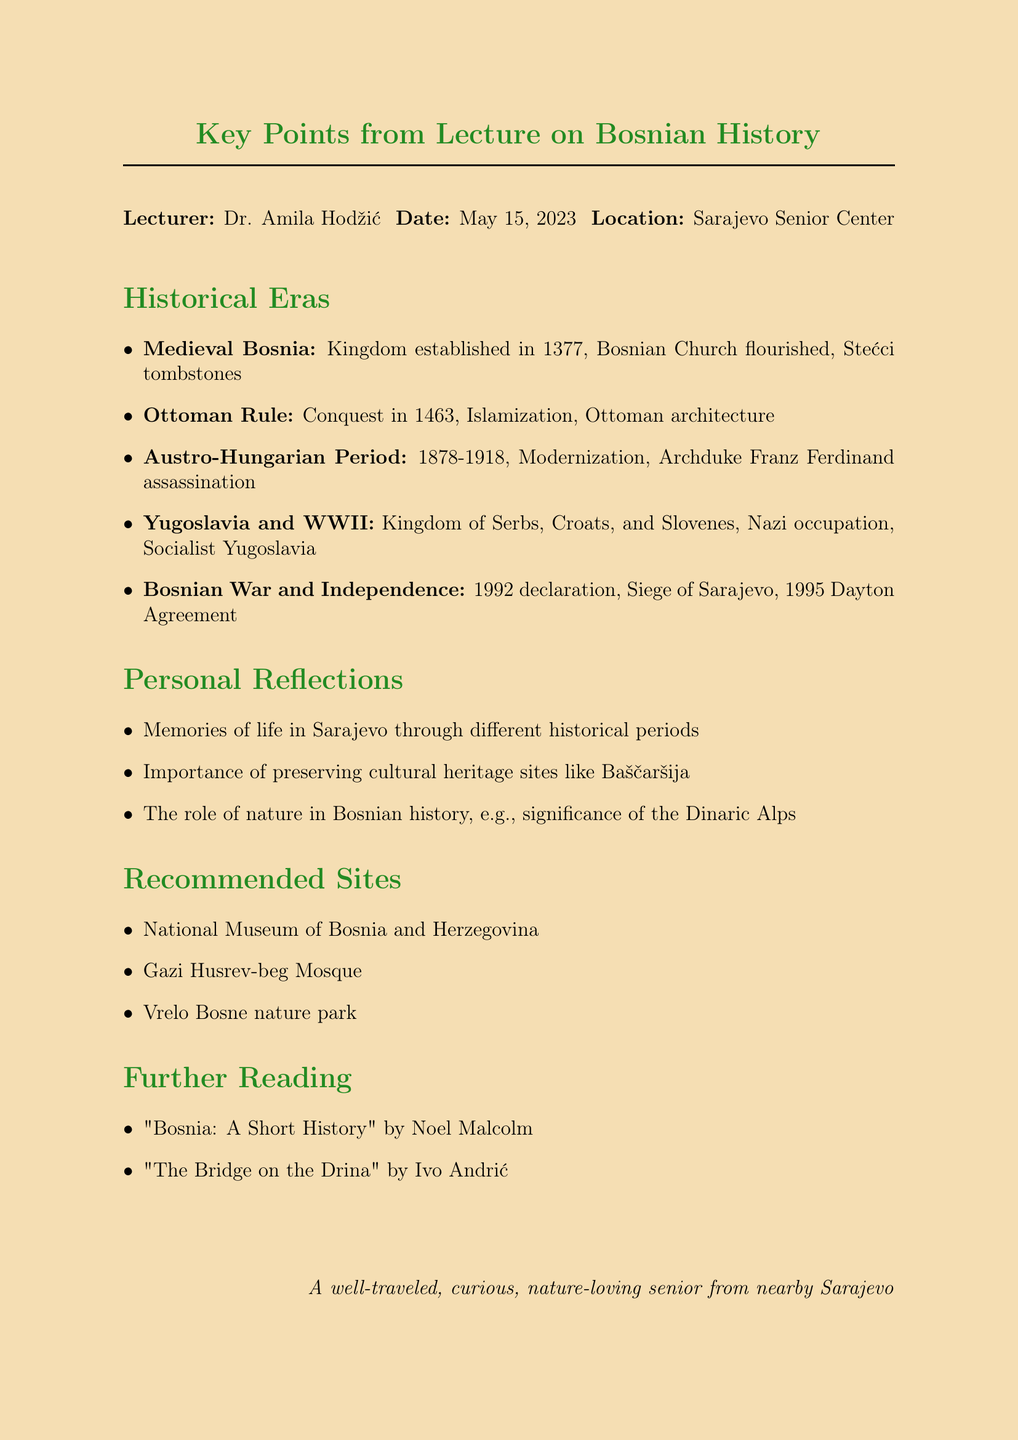What was the title of the lecture? The title of the lecture is mentioned at the top of the document.
Answer: Key Points from Lecture on Bosnian History Who was the lecturer? The lecturer's name is given in the document along with the title.
Answer: Dr. Amila Hodžić When was the lecture held? The date of the lecture is clearly stated in the document.
Answer: May 15, 2023 What was one of the recommended sites? The document lists several recommended sites at the end under a specific section.
Answer: National Museum of Bosnia and Herzegovina What year did the Kingdom of Bosnia get established? The establishment year is noted in the section on Medieval Bosnia.
Answer: 1377 During which period was Bosnia occupied by Austria-Hungary? The document provides specific dates for the Austro-Hungarian administration.
Answer: 1878 to 1918 How long did the Siege of Sarajevo last? The length of the siege is specified in the section on Bosnian War and Independence.
Answer: 1,425 days What is a key cultural heritage mentioned from the Medieval Bosnia era? The document references a specific cultural artifact from that era.
Answer: Stećci tombstones What is one of the personal reflections mentioned in the memo? Personal reflections are listed in a section of the document.
Answer: Importance of preserving cultural heritage sites like Baščaršija 